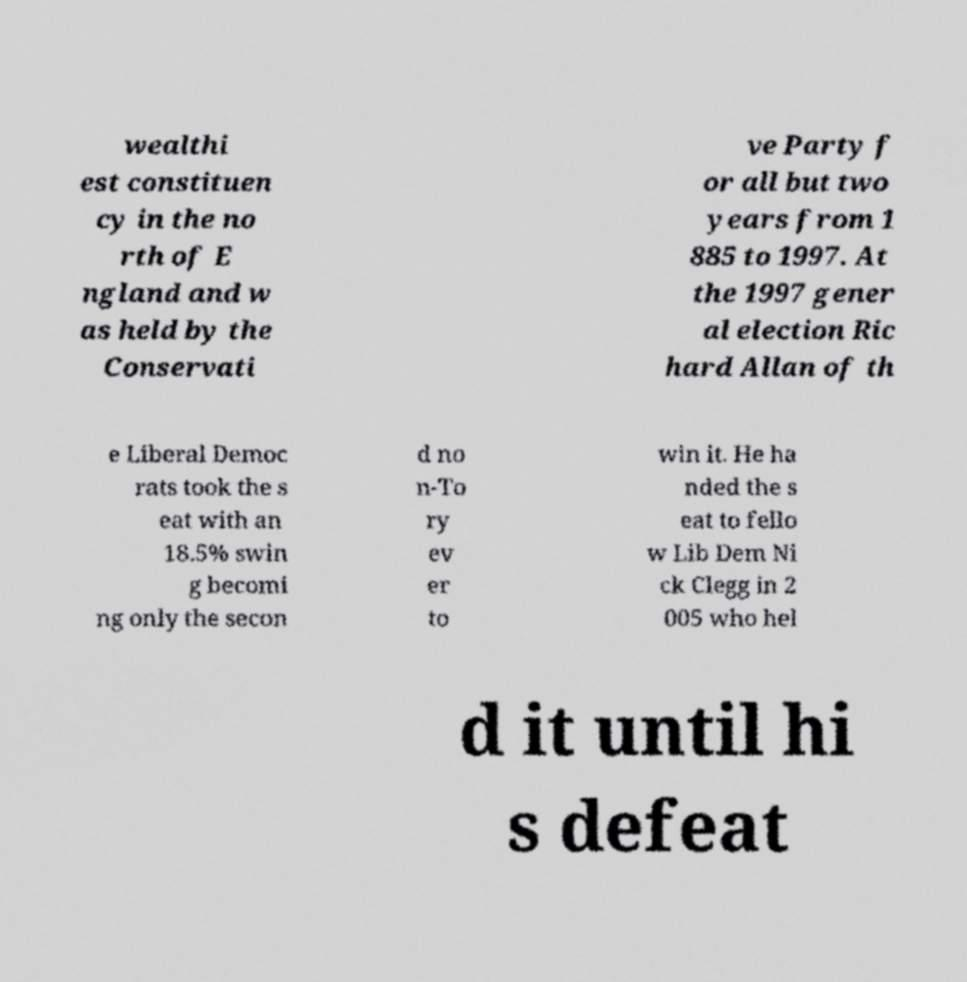Can you accurately transcribe the text from the provided image for me? wealthi est constituen cy in the no rth of E ngland and w as held by the Conservati ve Party f or all but two years from 1 885 to 1997. At the 1997 gener al election Ric hard Allan of th e Liberal Democ rats took the s eat with an 18.5% swin g becomi ng only the secon d no n-To ry ev er to win it. He ha nded the s eat to fello w Lib Dem Ni ck Clegg in 2 005 who hel d it until hi s defeat 